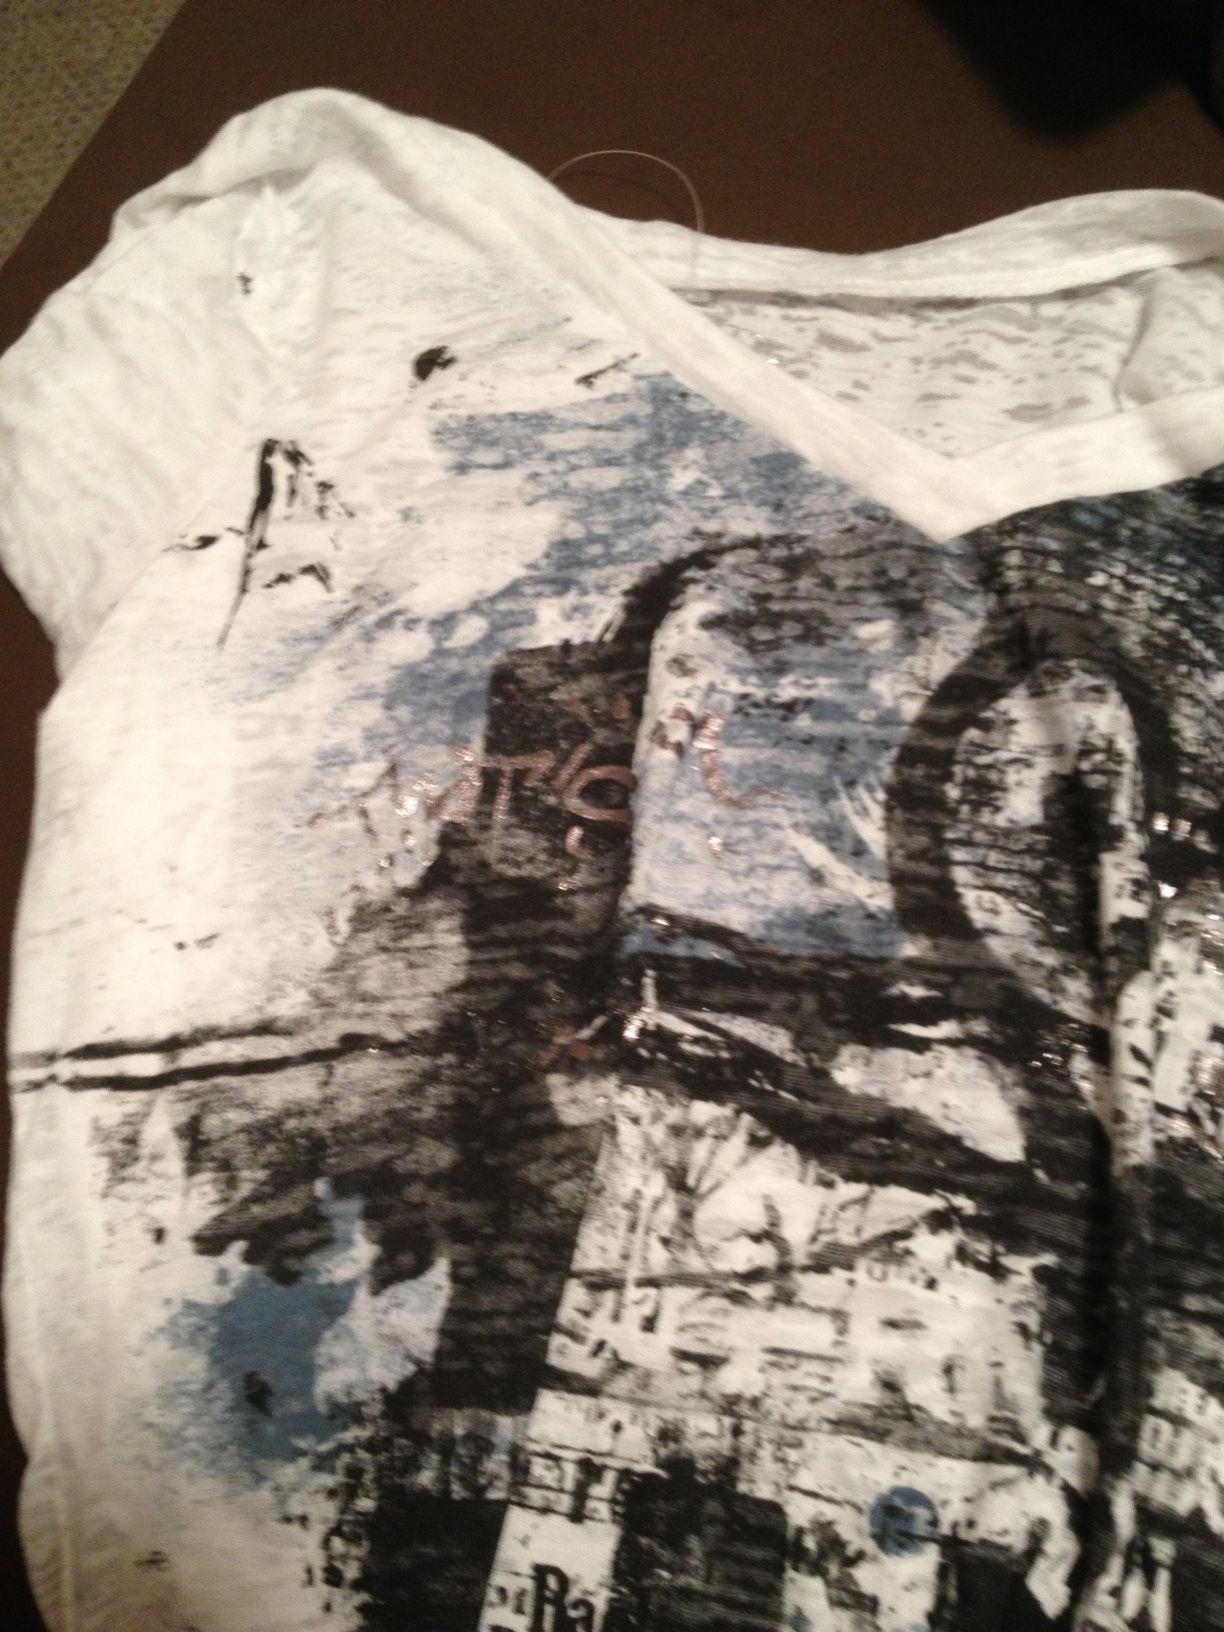Imagine the wearer of this shirt is attending an art gallery. What might they say about the art pieces there? As the wearer admired the diverse collection of artworks, they might say, 'The abstract pieces here resonate with my shirt's design. The chaotic yet harmonious blend of colors reminds me of the freedom and creativity in art. This gallery really captures the essence of outside-the-box thinking that I love.' 